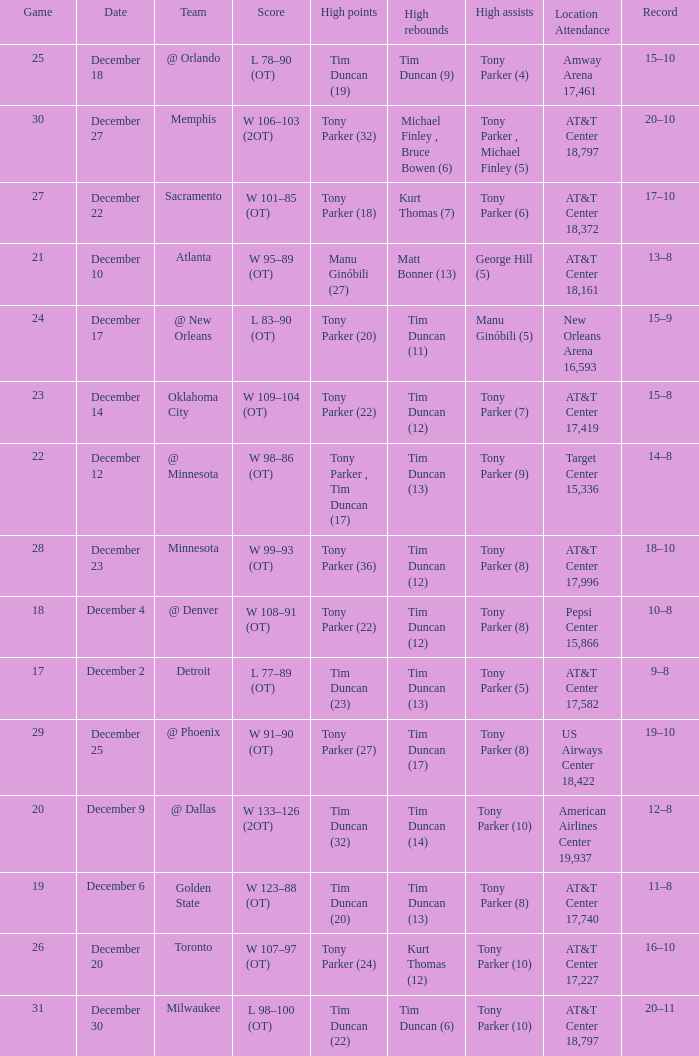What score has tim duncan (14) as the high rebounds? W 133–126 (2OT). 